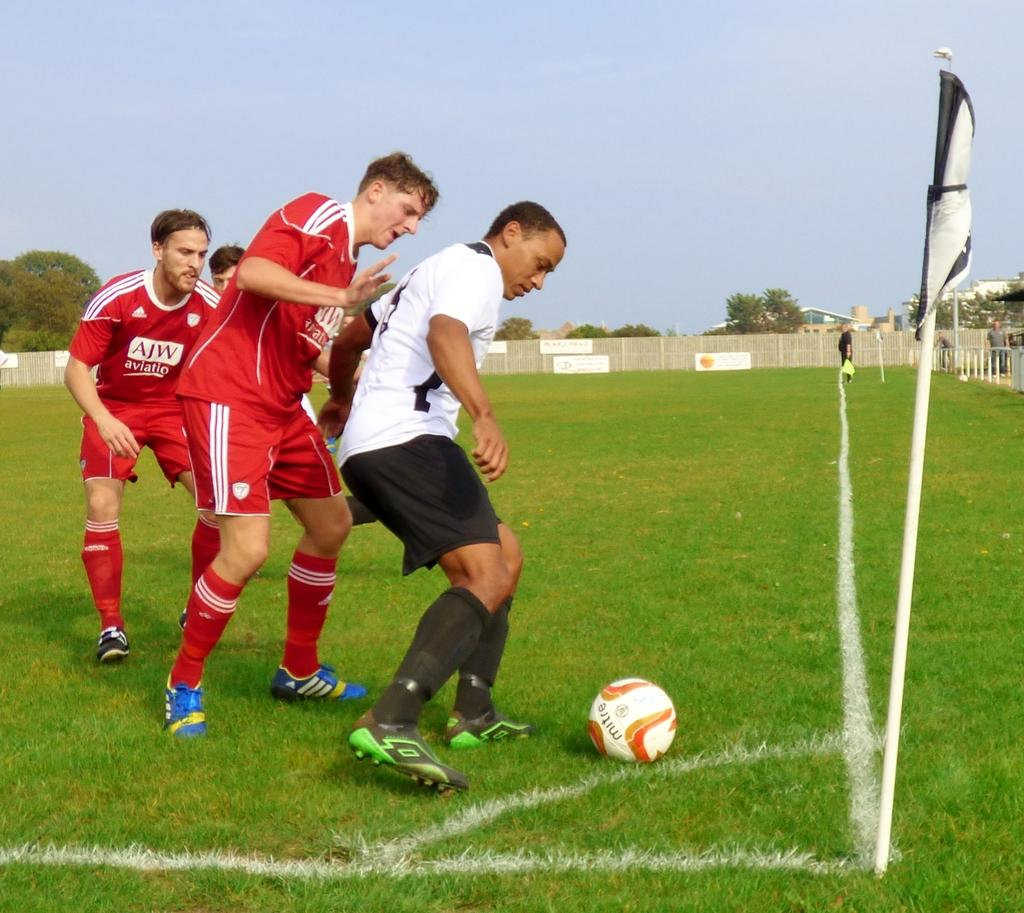What activity are the men in the image engaged in? The men in the image are playing football. What type of surface are they playing on? There is grass on the ground in the image. What structure can be seen in the image? There is a flagpole in the image. What type of barrier is present in the image? There is a fence in the image. What type of vegetation is visible in the image? There are trees in the image. What is the condition of the sky in the image? The sky is cloudy in the image. Where is the queen playing volleyball in the image? There is no queen or volleyball present in the image. What time is indicated by the clock in the image? There is no clock present in the image. 